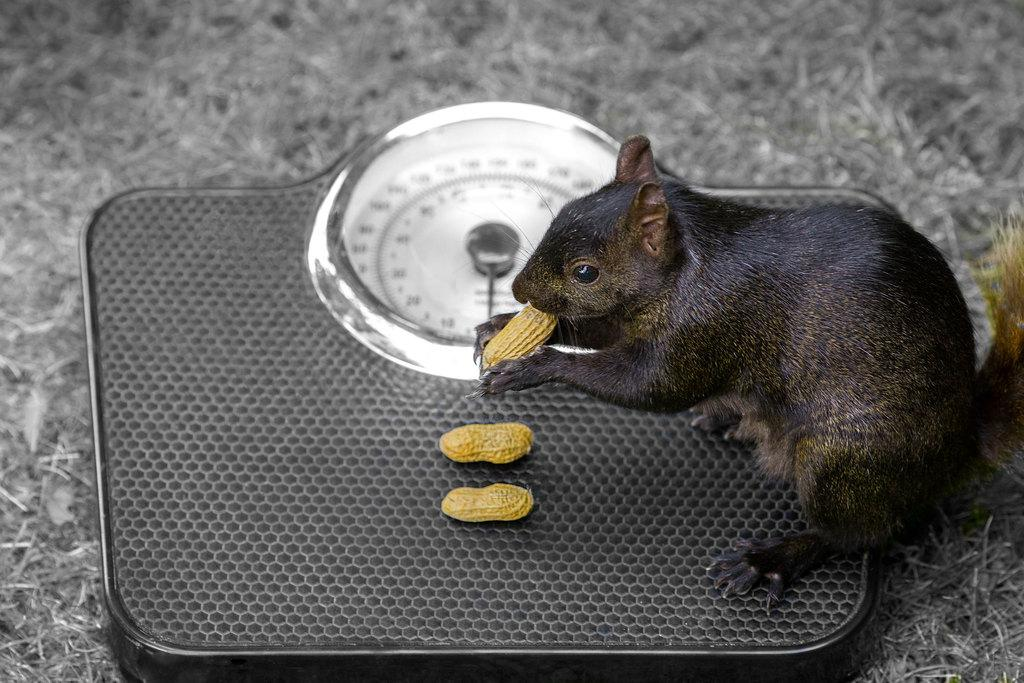What animal can be seen in the image? There is a mouse in the image. What is the mouse holding in its hands? The mouse is holding a yellow object. What can be seen on the weight scale machine in the image? There are yellow objects on a weight scale machine. What type of vegetation is visible on the ground? Some grass is visible on the ground. Can you hear the mouse coughing in the image? There is no indication of sound in the image, so it is not possible to determine if the mouse is coughing or not. 